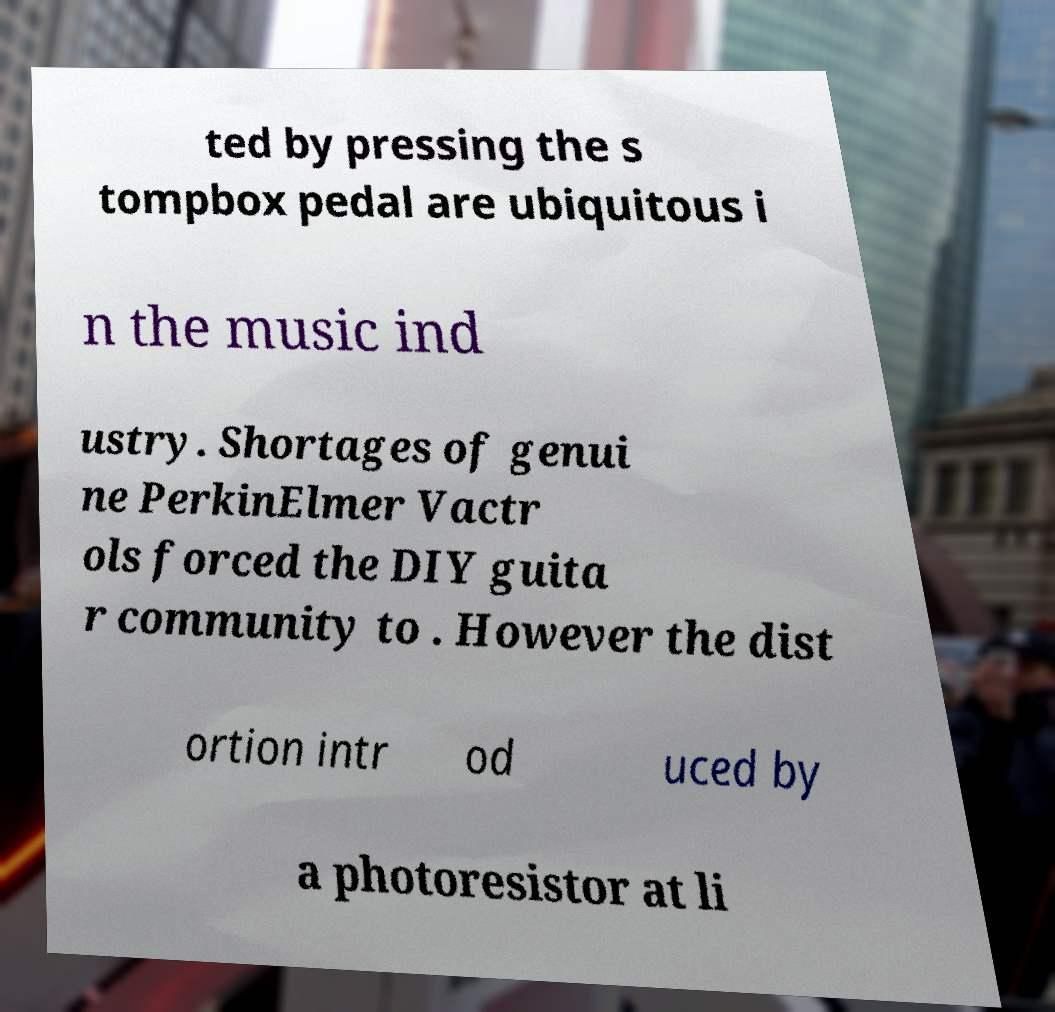Can you read and provide the text displayed in the image?This photo seems to have some interesting text. Can you extract and type it out for me? ted by pressing the s tompbox pedal are ubiquitous i n the music ind ustry. Shortages of genui ne PerkinElmer Vactr ols forced the DIY guita r community to . However the dist ortion intr od uced by a photoresistor at li 